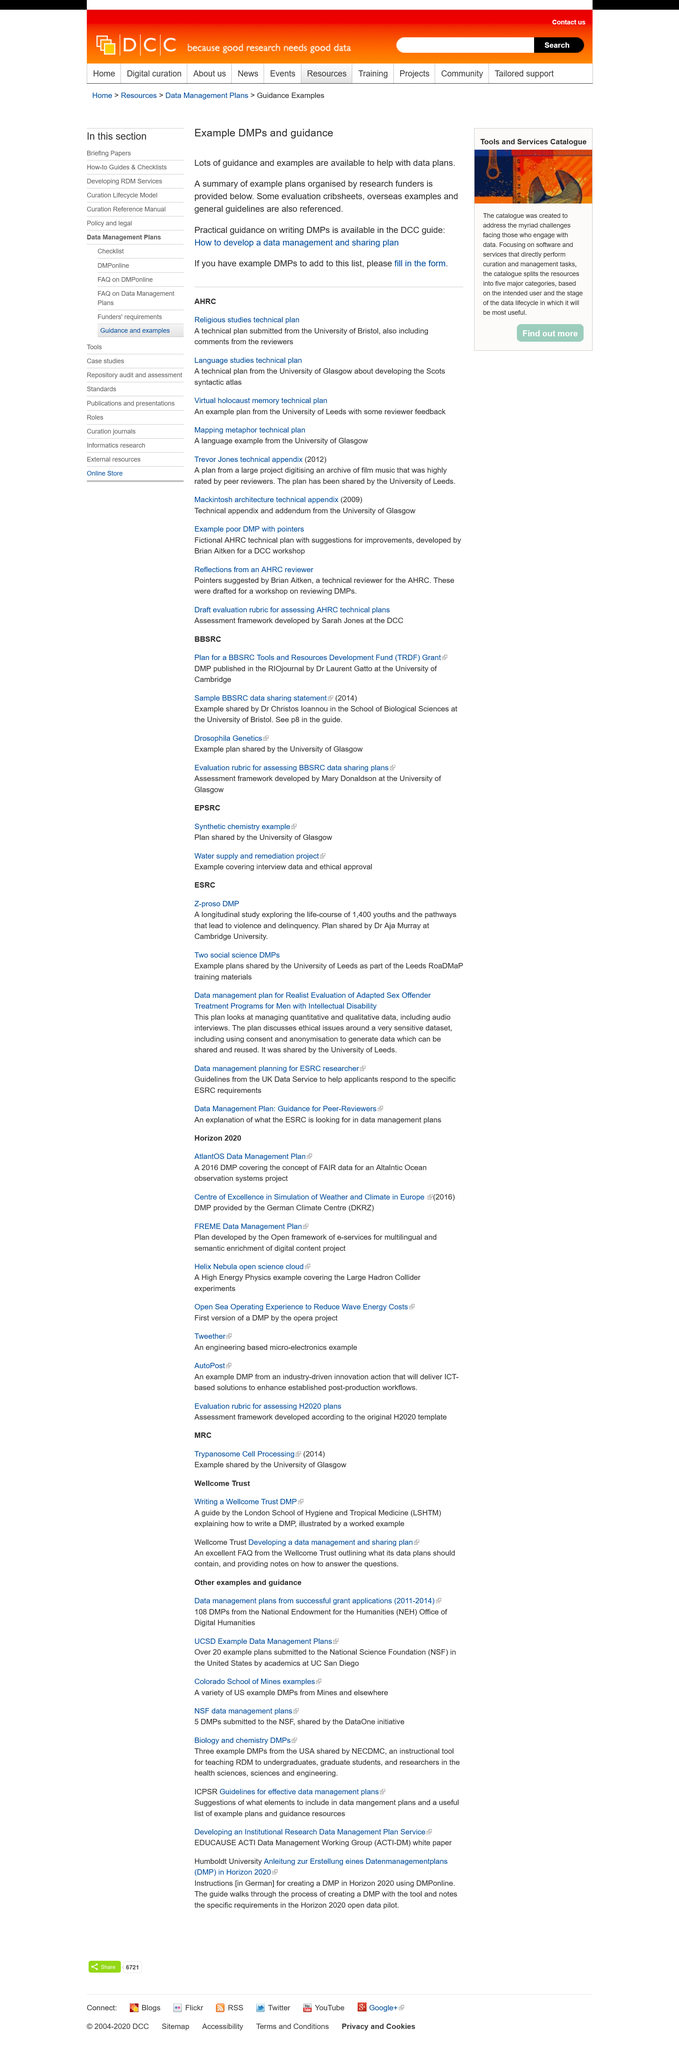Specify some key components in this picture. The DMP in the RIOjournal at the University of Cambridge was published by Dr. Laurent Gatto. Dr. Aja Murray works at Cambridge University. The University of Glasgow shared the Drosophila Genetics example plan. The Z-proso DMP study is a longitudinal investigation into the life courses of 1,400 youths and the various pathways that can lead to violence and delinquency. Data management and sharing plan, commonly referred to as DMP, is a document that outlines the procedures and guidelines for the effective management and sharing of research data. 